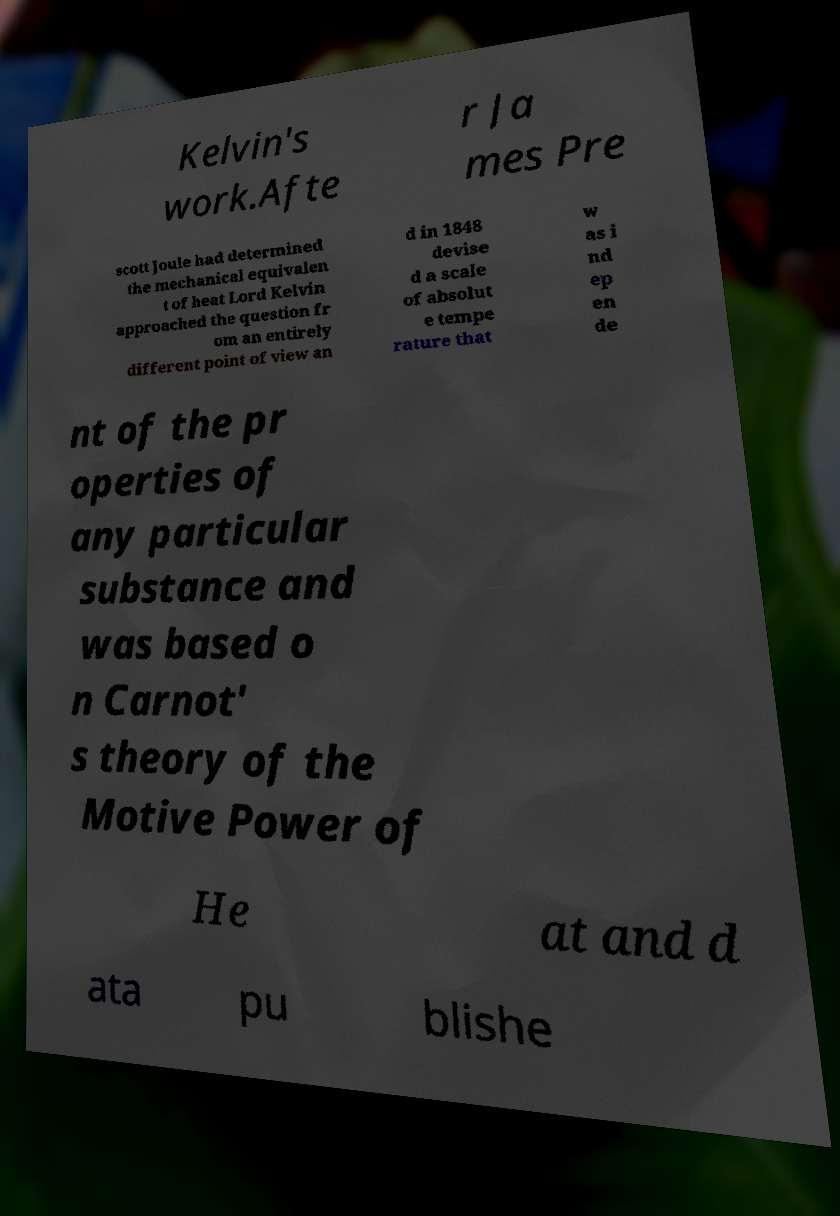Can you accurately transcribe the text from the provided image for me? Kelvin's work.Afte r Ja mes Pre scott Joule had determined the mechanical equivalen t of heat Lord Kelvin approached the question fr om an entirely different point of view an d in 1848 devise d a scale of absolut e tempe rature that w as i nd ep en de nt of the pr operties of any particular substance and was based o n Carnot' s theory of the Motive Power of He at and d ata pu blishe 